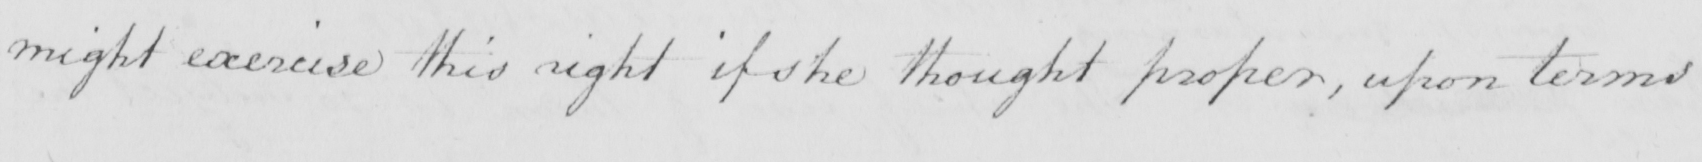Transcribe the text shown in this historical manuscript line. might exercise this right if she thought proper,upon terms 